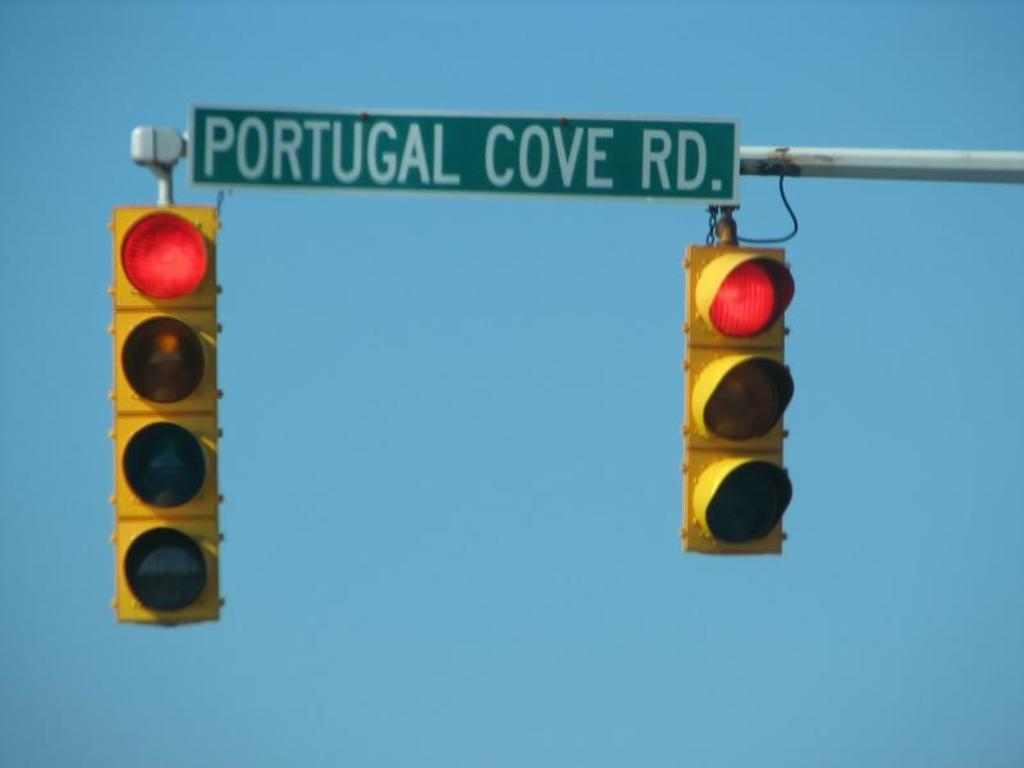<image>
Describe the image concisely. A pair of stop lights hanging from a bar with a Portugal Cove Rd. sign. 